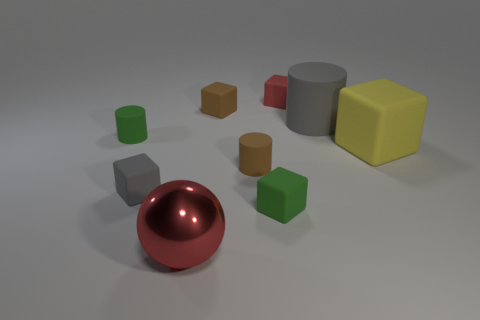Subtract all yellow rubber blocks. How many blocks are left? 4 Add 1 tiny cylinders. How many objects exist? 10 Subtract all brown blocks. How many blocks are left? 4 Subtract 2 blocks. How many blocks are left? 3 Subtract all cylinders. How many objects are left? 6 Subtract all yellow cylinders. Subtract all purple balls. How many cylinders are left? 3 Subtract all tiny brown cylinders. Subtract all large cyan metal cylinders. How many objects are left? 8 Add 8 red objects. How many red objects are left? 10 Add 3 small brown rubber blocks. How many small brown rubber blocks exist? 4 Subtract 0 cyan spheres. How many objects are left? 9 